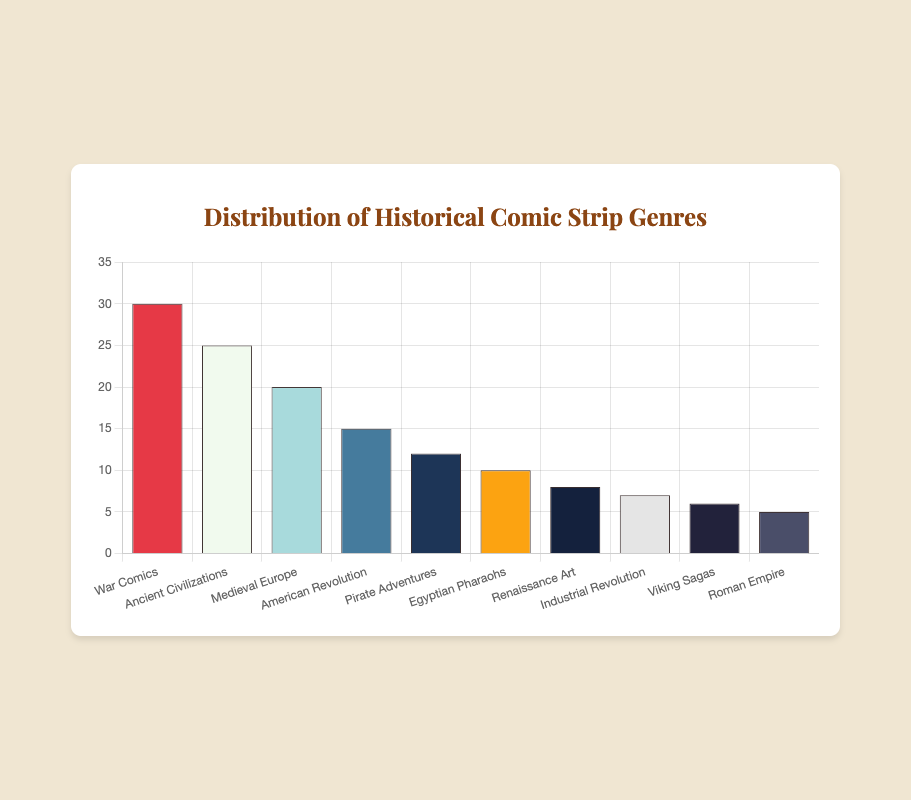What is the title of the chart? The title of the chart is displayed at the top of the figure and serves to describe what the chart represents. The title in this case is clearly stated as "Distribution of Historical Comic Strip Genres."
Answer: Distribution of Historical Comic Strip Genres What genre has the highest number of comics? The visual representation shows that the tallest bar in the chart represents the genre with the highest number of comics. The "War Comics" genre has the highest count with 30 comics.
Answer: War Comics How many comics are related to Ancient Civilizations? To find the number of comics related to Ancient Civilizations, look for the bar labeled "Ancient Civilizations" and check the corresponding value on the y-axis. The value is 25.
Answer: 25 Which genre has fewer comics: Viking Sagas or Renaissance Art? By comparing the heights of the bars for "Viking Sagas" and "Renaissance Art," it's clear that the "Viking Sagas" bar is shorter. "Viking Sagas" has 6 comics, and "Renaissance Art" has 8 comics.
Answer: Viking Sagas What is the total number of comics across all genres? Sum the values of all the bars: 30 (War Comics) + 25 (Ancient Civilizations) + 20 (Medieval Europe) + 15 (American Revolution) + 12 (Pirate Adventures) + 10 (Egyptian Pharaohs) + 8 (Renaissance Art) + 7 (Industrial Revolution) + 6 (Viking Sagas) + 5 (Roman Empire) = 138.
Answer: 138 Which genre has an emoji of a paint palette? The tooltip for "Renaissance Art" shows the emoji 🎨, indicating that this genre is associated with the paint palette emoji.
Answer: Renaissance Art What is the average number of comics per genre? To calculate the average, divide the total number of comics by the number of genres. Total is 138 comics, and there are 10 genres: 138 / 10 = 13.8.
Answer: 13.8 How many genres have at least 15 comics? By inspecting the chart, we see that "War Comics," "Ancient Civilizations," "Medieval Europe," and "American Revolution" each have at least 15 comics. That's 4 genres.
Answer: 4 Which two genres together have exactly 22 comics? By inspecting combinations of genres, we find that "Pirate Adventures" with 12 comics and "Egyptian Pharaohs" with 10 comics together total 22 comics.
Answer: Pirate Adventures and Egyptian Pharaohs 